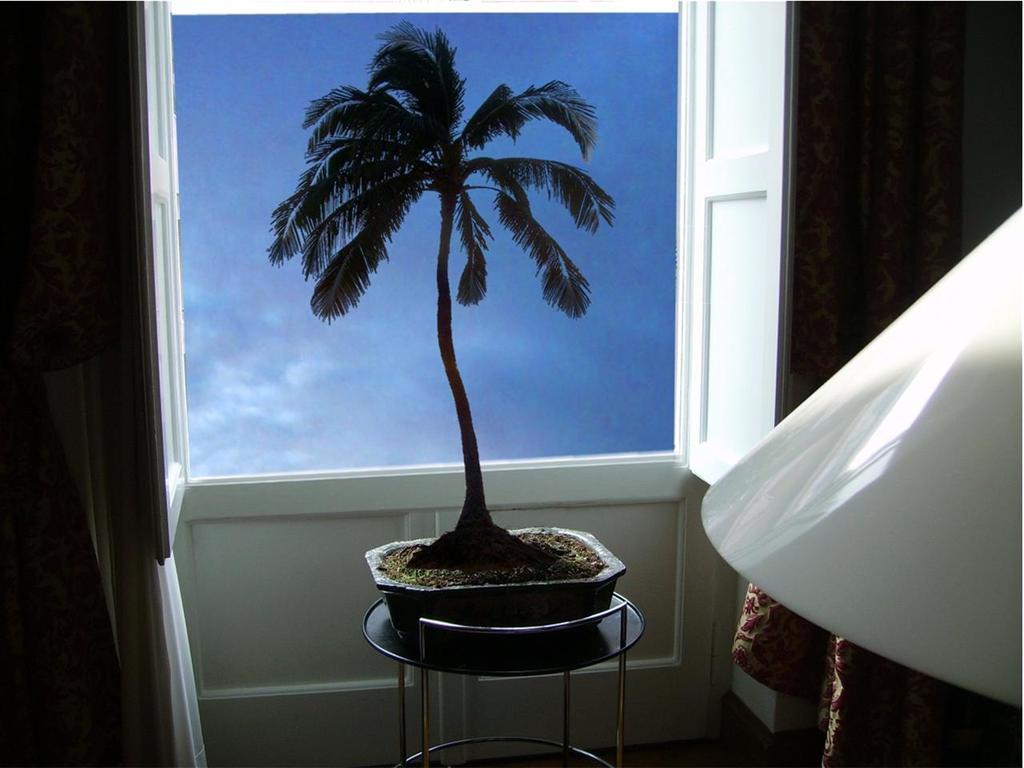Can you describe this image briefly? In this picture, we see a tube containing soil and plant is placed on the stool. Behind that, we see a window from which we can see the sky, which is blue in color. In the right bottom of the picture, we see a white colored cloth. 